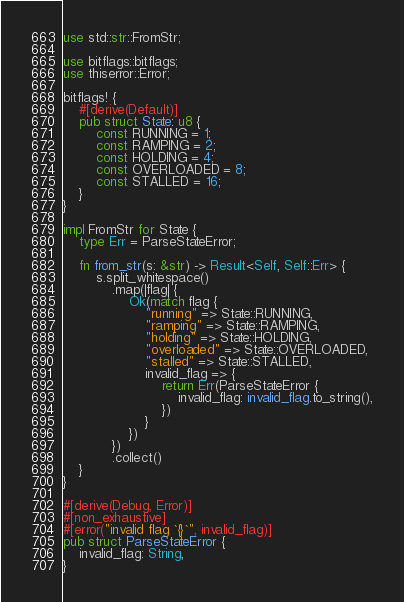Convert code to text. <code><loc_0><loc_0><loc_500><loc_500><_Rust_>use std::str::FromStr;

use bitflags::bitflags;
use thiserror::Error;

bitflags! {
    #[derive(Default)]
    pub struct State: u8 {
        const RUNNING = 1;
        const RAMPING = 2;
        const HOLDING = 4;
        const OVERLOADED = 8;
        const STALLED = 16;
    }
}

impl FromStr for State {
    type Err = ParseStateError;

    fn from_str(s: &str) -> Result<Self, Self::Err> {
        s.split_whitespace()
            .map(|flag| {
                Ok(match flag {
                    "running" => State::RUNNING,
                    "ramping" => State::RAMPING,
                    "holding" => State::HOLDING,
                    "overloaded" => State::OVERLOADED,
                    "stalled" => State::STALLED,
                    invalid_flag => {
                        return Err(ParseStateError {
                            invalid_flag: invalid_flag.to_string(),
                        })
                    }
                })
            })
            .collect()
    }
}

#[derive(Debug, Error)]
#[non_exhaustive]
#[error("invalid flag `{}`", invalid_flag)]
pub struct ParseStateError {
    invalid_flag: String,
}
</code> 